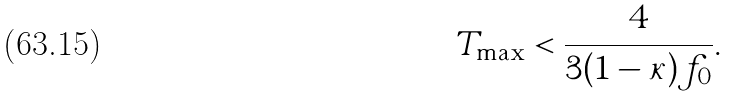Convert formula to latex. <formula><loc_0><loc_0><loc_500><loc_500>T _ { \max } < \frac { 4 } { 3 ( 1 - \kappa ) f _ { 0 } } .</formula> 